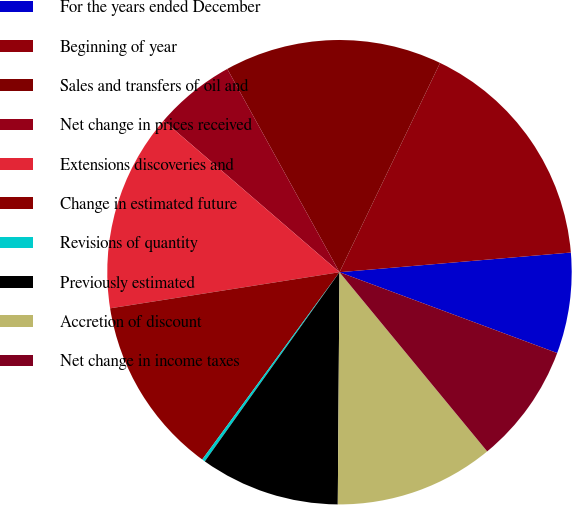<chart> <loc_0><loc_0><loc_500><loc_500><pie_chart><fcel>For the years ended December<fcel>Beginning of year<fcel>Sales and transfers of oil and<fcel>Net change in prices received<fcel>Extensions discoveries and<fcel>Change in estimated future<fcel>Revisions of quantity<fcel>Previously estimated<fcel>Accretion of discount<fcel>Net change in income taxes<nl><fcel>7.01%<fcel>16.52%<fcel>15.16%<fcel>5.65%<fcel>13.81%<fcel>12.45%<fcel>0.22%<fcel>9.73%<fcel>11.09%<fcel>8.37%<nl></chart> 